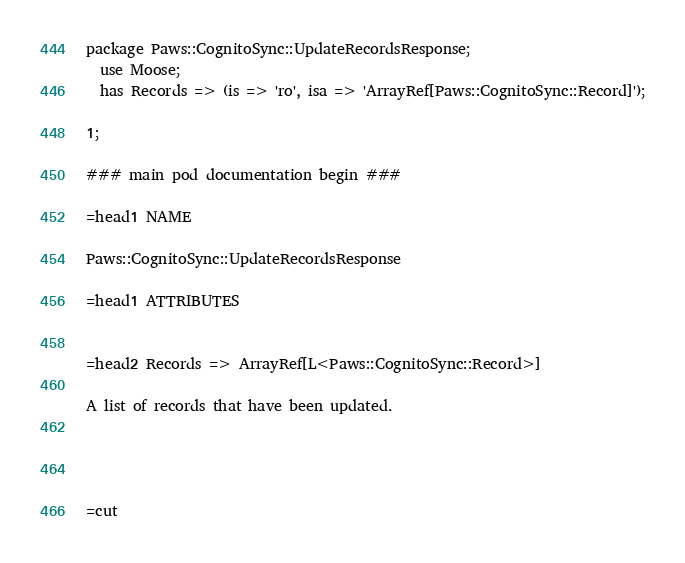Convert code to text. <code><loc_0><loc_0><loc_500><loc_500><_Perl_>
package Paws::CognitoSync::UpdateRecordsResponse;
  use Moose;
  has Records => (is => 'ro', isa => 'ArrayRef[Paws::CognitoSync::Record]');

1;

### main pod documentation begin ###

=head1 NAME

Paws::CognitoSync::UpdateRecordsResponse

=head1 ATTRIBUTES


=head2 Records => ArrayRef[L<Paws::CognitoSync::Record>]

A list of records that have been updated.




=cut

</code> 